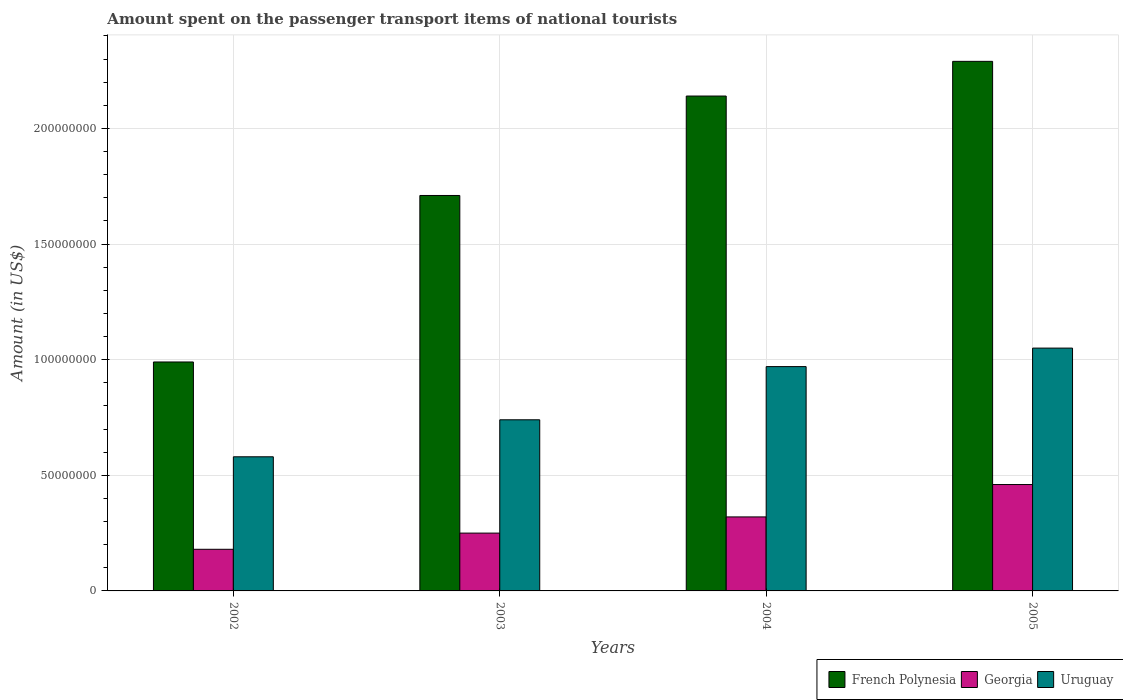How many different coloured bars are there?
Keep it short and to the point. 3. Are the number of bars per tick equal to the number of legend labels?
Offer a terse response. Yes. How many bars are there on the 2nd tick from the left?
Provide a short and direct response. 3. How many bars are there on the 2nd tick from the right?
Make the answer very short. 3. What is the amount spent on the passenger transport items of national tourists in Uruguay in 2004?
Give a very brief answer. 9.70e+07. Across all years, what is the maximum amount spent on the passenger transport items of national tourists in French Polynesia?
Keep it short and to the point. 2.29e+08. Across all years, what is the minimum amount spent on the passenger transport items of national tourists in Uruguay?
Offer a very short reply. 5.80e+07. In which year was the amount spent on the passenger transport items of national tourists in Georgia minimum?
Keep it short and to the point. 2002. What is the total amount spent on the passenger transport items of national tourists in Uruguay in the graph?
Offer a very short reply. 3.34e+08. What is the difference between the amount spent on the passenger transport items of national tourists in Uruguay in 2002 and that in 2003?
Your response must be concise. -1.60e+07. What is the difference between the amount spent on the passenger transport items of national tourists in Uruguay in 2003 and the amount spent on the passenger transport items of national tourists in French Polynesia in 2002?
Your answer should be compact. -2.50e+07. What is the average amount spent on the passenger transport items of national tourists in Uruguay per year?
Offer a very short reply. 8.35e+07. In the year 2005, what is the difference between the amount spent on the passenger transport items of national tourists in Uruguay and amount spent on the passenger transport items of national tourists in French Polynesia?
Your response must be concise. -1.24e+08. What is the ratio of the amount spent on the passenger transport items of national tourists in Uruguay in 2003 to that in 2005?
Give a very brief answer. 0.7. What is the difference between the highest and the second highest amount spent on the passenger transport items of national tourists in French Polynesia?
Ensure brevity in your answer.  1.50e+07. What is the difference between the highest and the lowest amount spent on the passenger transport items of national tourists in French Polynesia?
Ensure brevity in your answer.  1.30e+08. Is the sum of the amount spent on the passenger transport items of national tourists in French Polynesia in 2002 and 2005 greater than the maximum amount spent on the passenger transport items of national tourists in Uruguay across all years?
Offer a very short reply. Yes. What does the 3rd bar from the left in 2005 represents?
Provide a short and direct response. Uruguay. What does the 2nd bar from the right in 2003 represents?
Provide a short and direct response. Georgia. Are all the bars in the graph horizontal?
Your answer should be compact. No. How many years are there in the graph?
Offer a very short reply. 4. How many legend labels are there?
Provide a succinct answer. 3. How are the legend labels stacked?
Your answer should be compact. Horizontal. What is the title of the graph?
Your response must be concise. Amount spent on the passenger transport items of national tourists. What is the label or title of the Y-axis?
Keep it short and to the point. Amount (in US$). What is the Amount (in US$) in French Polynesia in 2002?
Give a very brief answer. 9.90e+07. What is the Amount (in US$) of Georgia in 2002?
Offer a terse response. 1.80e+07. What is the Amount (in US$) in Uruguay in 2002?
Give a very brief answer. 5.80e+07. What is the Amount (in US$) of French Polynesia in 2003?
Provide a short and direct response. 1.71e+08. What is the Amount (in US$) of Georgia in 2003?
Ensure brevity in your answer.  2.50e+07. What is the Amount (in US$) in Uruguay in 2003?
Your response must be concise. 7.40e+07. What is the Amount (in US$) in French Polynesia in 2004?
Provide a succinct answer. 2.14e+08. What is the Amount (in US$) of Georgia in 2004?
Offer a terse response. 3.20e+07. What is the Amount (in US$) of Uruguay in 2004?
Provide a short and direct response. 9.70e+07. What is the Amount (in US$) of French Polynesia in 2005?
Your answer should be very brief. 2.29e+08. What is the Amount (in US$) in Georgia in 2005?
Give a very brief answer. 4.60e+07. What is the Amount (in US$) in Uruguay in 2005?
Your response must be concise. 1.05e+08. Across all years, what is the maximum Amount (in US$) of French Polynesia?
Your answer should be very brief. 2.29e+08. Across all years, what is the maximum Amount (in US$) in Georgia?
Keep it short and to the point. 4.60e+07. Across all years, what is the maximum Amount (in US$) of Uruguay?
Ensure brevity in your answer.  1.05e+08. Across all years, what is the minimum Amount (in US$) in French Polynesia?
Ensure brevity in your answer.  9.90e+07. Across all years, what is the minimum Amount (in US$) in Georgia?
Provide a short and direct response. 1.80e+07. Across all years, what is the minimum Amount (in US$) in Uruguay?
Your answer should be compact. 5.80e+07. What is the total Amount (in US$) in French Polynesia in the graph?
Give a very brief answer. 7.13e+08. What is the total Amount (in US$) of Georgia in the graph?
Make the answer very short. 1.21e+08. What is the total Amount (in US$) of Uruguay in the graph?
Give a very brief answer. 3.34e+08. What is the difference between the Amount (in US$) in French Polynesia in 2002 and that in 2003?
Ensure brevity in your answer.  -7.20e+07. What is the difference between the Amount (in US$) in Georgia in 2002 and that in 2003?
Offer a very short reply. -7.00e+06. What is the difference between the Amount (in US$) in Uruguay in 2002 and that in 2003?
Offer a very short reply. -1.60e+07. What is the difference between the Amount (in US$) of French Polynesia in 2002 and that in 2004?
Provide a succinct answer. -1.15e+08. What is the difference between the Amount (in US$) in Georgia in 2002 and that in 2004?
Keep it short and to the point. -1.40e+07. What is the difference between the Amount (in US$) of Uruguay in 2002 and that in 2004?
Make the answer very short. -3.90e+07. What is the difference between the Amount (in US$) in French Polynesia in 2002 and that in 2005?
Your response must be concise. -1.30e+08. What is the difference between the Amount (in US$) of Georgia in 2002 and that in 2005?
Provide a short and direct response. -2.80e+07. What is the difference between the Amount (in US$) of Uruguay in 2002 and that in 2005?
Make the answer very short. -4.70e+07. What is the difference between the Amount (in US$) in French Polynesia in 2003 and that in 2004?
Ensure brevity in your answer.  -4.30e+07. What is the difference between the Amount (in US$) of Georgia in 2003 and that in 2004?
Keep it short and to the point. -7.00e+06. What is the difference between the Amount (in US$) in Uruguay in 2003 and that in 2004?
Give a very brief answer. -2.30e+07. What is the difference between the Amount (in US$) in French Polynesia in 2003 and that in 2005?
Offer a terse response. -5.80e+07. What is the difference between the Amount (in US$) in Georgia in 2003 and that in 2005?
Make the answer very short. -2.10e+07. What is the difference between the Amount (in US$) in Uruguay in 2003 and that in 2005?
Ensure brevity in your answer.  -3.10e+07. What is the difference between the Amount (in US$) in French Polynesia in 2004 and that in 2005?
Offer a terse response. -1.50e+07. What is the difference between the Amount (in US$) of Georgia in 2004 and that in 2005?
Give a very brief answer. -1.40e+07. What is the difference between the Amount (in US$) of Uruguay in 2004 and that in 2005?
Your answer should be very brief. -8.00e+06. What is the difference between the Amount (in US$) of French Polynesia in 2002 and the Amount (in US$) of Georgia in 2003?
Your answer should be very brief. 7.40e+07. What is the difference between the Amount (in US$) of French Polynesia in 2002 and the Amount (in US$) of Uruguay in 2003?
Provide a short and direct response. 2.50e+07. What is the difference between the Amount (in US$) of Georgia in 2002 and the Amount (in US$) of Uruguay in 2003?
Provide a short and direct response. -5.60e+07. What is the difference between the Amount (in US$) in French Polynesia in 2002 and the Amount (in US$) in Georgia in 2004?
Ensure brevity in your answer.  6.70e+07. What is the difference between the Amount (in US$) in Georgia in 2002 and the Amount (in US$) in Uruguay in 2004?
Keep it short and to the point. -7.90e+07. What is the difference between the Amount (in US$) of French Polynesia in 2002 and the Amount (in US$) of Georgia in 2005?
Ensure brevity in your answer.  5.30e+07. What is the difference between the Amount (in US$) of French Polynesia in 2002 and the Amount (in US$) of Uruguay in 2005?
Provide a short and direct response. -6.00e+06. What is the difference between the Amount (in US$) of Georgia in 2002 and the Amount (in US$) of Uruguay in 2005?
Offer a very short reply. -8.70e+07. What is the difference between the Amount (in US$) of French Polynesia in 2003 and the Amount (in US$) of Georgia in 2004?
Give a very brief answer. 1.39e+08. What is the difference between the Amount (in US$) of French Polynesia in 2003 and the Amount (in US$) of Uruguay in 2004?
Keep it short and to the point. 7.40e+07. What is the difference between the Amount (in US$) in Georgia in 2003 and the Amount (in US$) in Uruguay in 2004?
Ensure brevity in your answer.  -7.20e+07. What is the difference between the Amount (in US$) in French Polynesia in 2003 and the Amount (in US$) in Georgia in 2005?
Provide a short and direct response. 1.25e+08. What is the difference between the Amount (in US$) of French Polynesia in 2003 and the Amount (in US$) of Uruguay in 2005?
Provide a succinct answer. 6.60e+07. What is the difference between the Amount (in US$) in Georgia in 2003 and the Amount (in US$) in Uruguay in 2005?
Give a very brief answer. -8.00e+07. What is the difference between the Amount (in US$) in French Polynesia in 2004 and the Amount (in US$) in Georgia in 2005?
Keep it short and to the point. 1.68e+08. What is the difference between the Amount (in US$) in French Polynesia in 2004 and the Amount (in US$) in Uruguay in 2005?
Make the answer very short. 1.09e+08. What is the difference between the Amount (in US$) in Georgia in 2004 and the Amount (in US$) in Uruguay in 2005?
Provide a short and direct response. -7.30e+07. What is the average Amount (in US$) of French Polynesia per year?
Make the answer very short. 1.78e+08. What is the average Amount (in US$) of Georgia per year?
Your response must be concise. 3.02e+07. What is the average Amount (in US$) in Uruguay per year?
Give a very brief answer. 8.35e+07. In the year 2002, what is the difference between the Amount (in US$) in French Polynesia and Amount (in US$) in Georgia?
Ensure brevity in your answer.  8.10e+07. In the year 2002, what is the difference between the Amount (in US$) in French Polynesia and Amount (in US$) in Uruguay?
Your response must be concise. 4.10e+07. In the year 2002, what is the difference between the Amount (in US$) in Georgia and Amount (in US$) in Uruguay?
Your response must be concise. -4.00e+07. In the year 2003, what is the difference between the Amount (in US$) in French Polynesia and Amount (in US$) in Georgia?
Offer a very short reply. 1.46e+08. In the year 2003, what is the difference between the Amount (in US$) of French Polynesia and Amount (in US$) of Uruguay?
Your answer should be very brief. 9.70e+07. In the year 2003, what is the difference between the Amount (in US$) of Georgia and Amount (in US$) of Uruguay?
Provide a short and direct response. -4.90e+07. In the year 2004, what is the difference between the Amount (in US$) in French Polynesia and Amount (in US$) in Georgia?
Keep it short and to the point. 1.82e+08. In the year 2004, what is the difference between the Amount (in US$) of French Polynesia and Amount (in US$) of Uruguay?
Provide a succinct answer. 1.17e+08. In the year 2004, what is the difference between the Amount (in US$) in Georgia and Amount (in US$) in Uruguay?
Your response must be concise. -6.50e+07. In the year 2005, what is the difference between the Amount (in US$) of French Polynesia and Amount (in US$) of Georgia?
Your answer should be very brief. 1.83e+08. In the year 2005, what is the difference between the Amount (in US$) of French Polynesia and Amount (in US$) of Uruguay?
Give a very brief answer. 1.24e+08. In the year 2005, what is the difference between the Amount (in US$) of Georgia and Amount (in US$) of Uruguay?
Provide a succinct answer. -5.90e+07. What is the ratio of the Amount (in US$) of French Polynesia in 2002 to that in 2003?
Your answer should be compact. 0.58. What is the ratio of the Amount (in US$) in Georgia in 2002 to that in 2003?
Your answer should be compact. 0.72. What is the ratio of the Amount (in US$) in Uruguay in 2002 to that in 2003?
Your response must be concise. 0.78. What is the ratio of the Amount (in US$) in French Polynesia in 2002 to that in 2004?
Keep it short and to the point. 0.46. What is the ratio of the Amount (in US$) of Georgia in 2002 to that in 2004?
Ensure brevity in your answer.  0.56. What is the ratio of the Amount (in US$) in Uruguay in 2002 to that in 2004?
Ensure brevity in your answer.  0.6. What is the ratio of the Amount (in US$) of French Polynesia in 2002 to that in 2005?
Provide a short and direct response. 0.43. What is the ratio of the Amount (in US$) in Georgia in 2002 to that in 2005?
Your answer should be compact. 0.39. What is the ratio of the Amount (in US$) of Uruguay in 2002 to that in 2005?
Ensure brevity in your answer.  0.55. What is the ratio of the Amount (in US$) in French Polynesia in 2003 to that in 2004?
Offer a very short reply. 0.8. What is the ratio of the Amount (in US$) in Georgia in 2003 to that in 2004?
Make the answer very short. 0.78. What is the ratio of the Amount (in US$) in Uruguay in 2003 to that in 2004?
Make the answer very short. 0.76. What is the ratio of the Amount (in US$) of French Polynesia in 2003 to that in 2005?
Provide a succinct answer. 0.75. What is the ratio of the Amount (in US$) of Georgia in 2003 to that in 2005?
Make the answer very short. 0.54. What is the ratio of the Amount (in US$) of Uruguay in 2003 to that in 2005?
Keep it short and to the point. 0.7. What is the ratio of the Amount (in US$) of French Polynesia in 2004 to that in 2005?
Provide a succinct answer. 0.93. What is the ratio of the Amount (in US$) of Georgia in 2004 to that in 2005?
Make the answer very short. 0.7. What is the ratio of the Amount (in US$) in Uruguay in 2004 to that in 2005?
Ensure brevity in your answer.  0.92. What is the difference between the highest and the second highest Amount (in US$) of French Polynesia?
Provide a short and direct response. 1.50e+07. What is the difference between the highest and the second highest Amount (in US$) of Georgia?
Offer a terse response. 1.40e+07. What is the difference between the highest and the second highest Amount (in US$) of Uruguay?
Offer a terse response. 8.00e+06. What is the difference between the highest and the lowest Amount (in US$) in French Polynesia?
Make the answer very short. 1.30e+08. What is the difference between the highest and the lowest Amount (in US$) of Georgia?
Provide a short and direct response. 2.80e+07. What is the difference between the highest and the lowest Amount (in US$) in Uruguay?
Keep it short and to the point. 4.70e+07. 